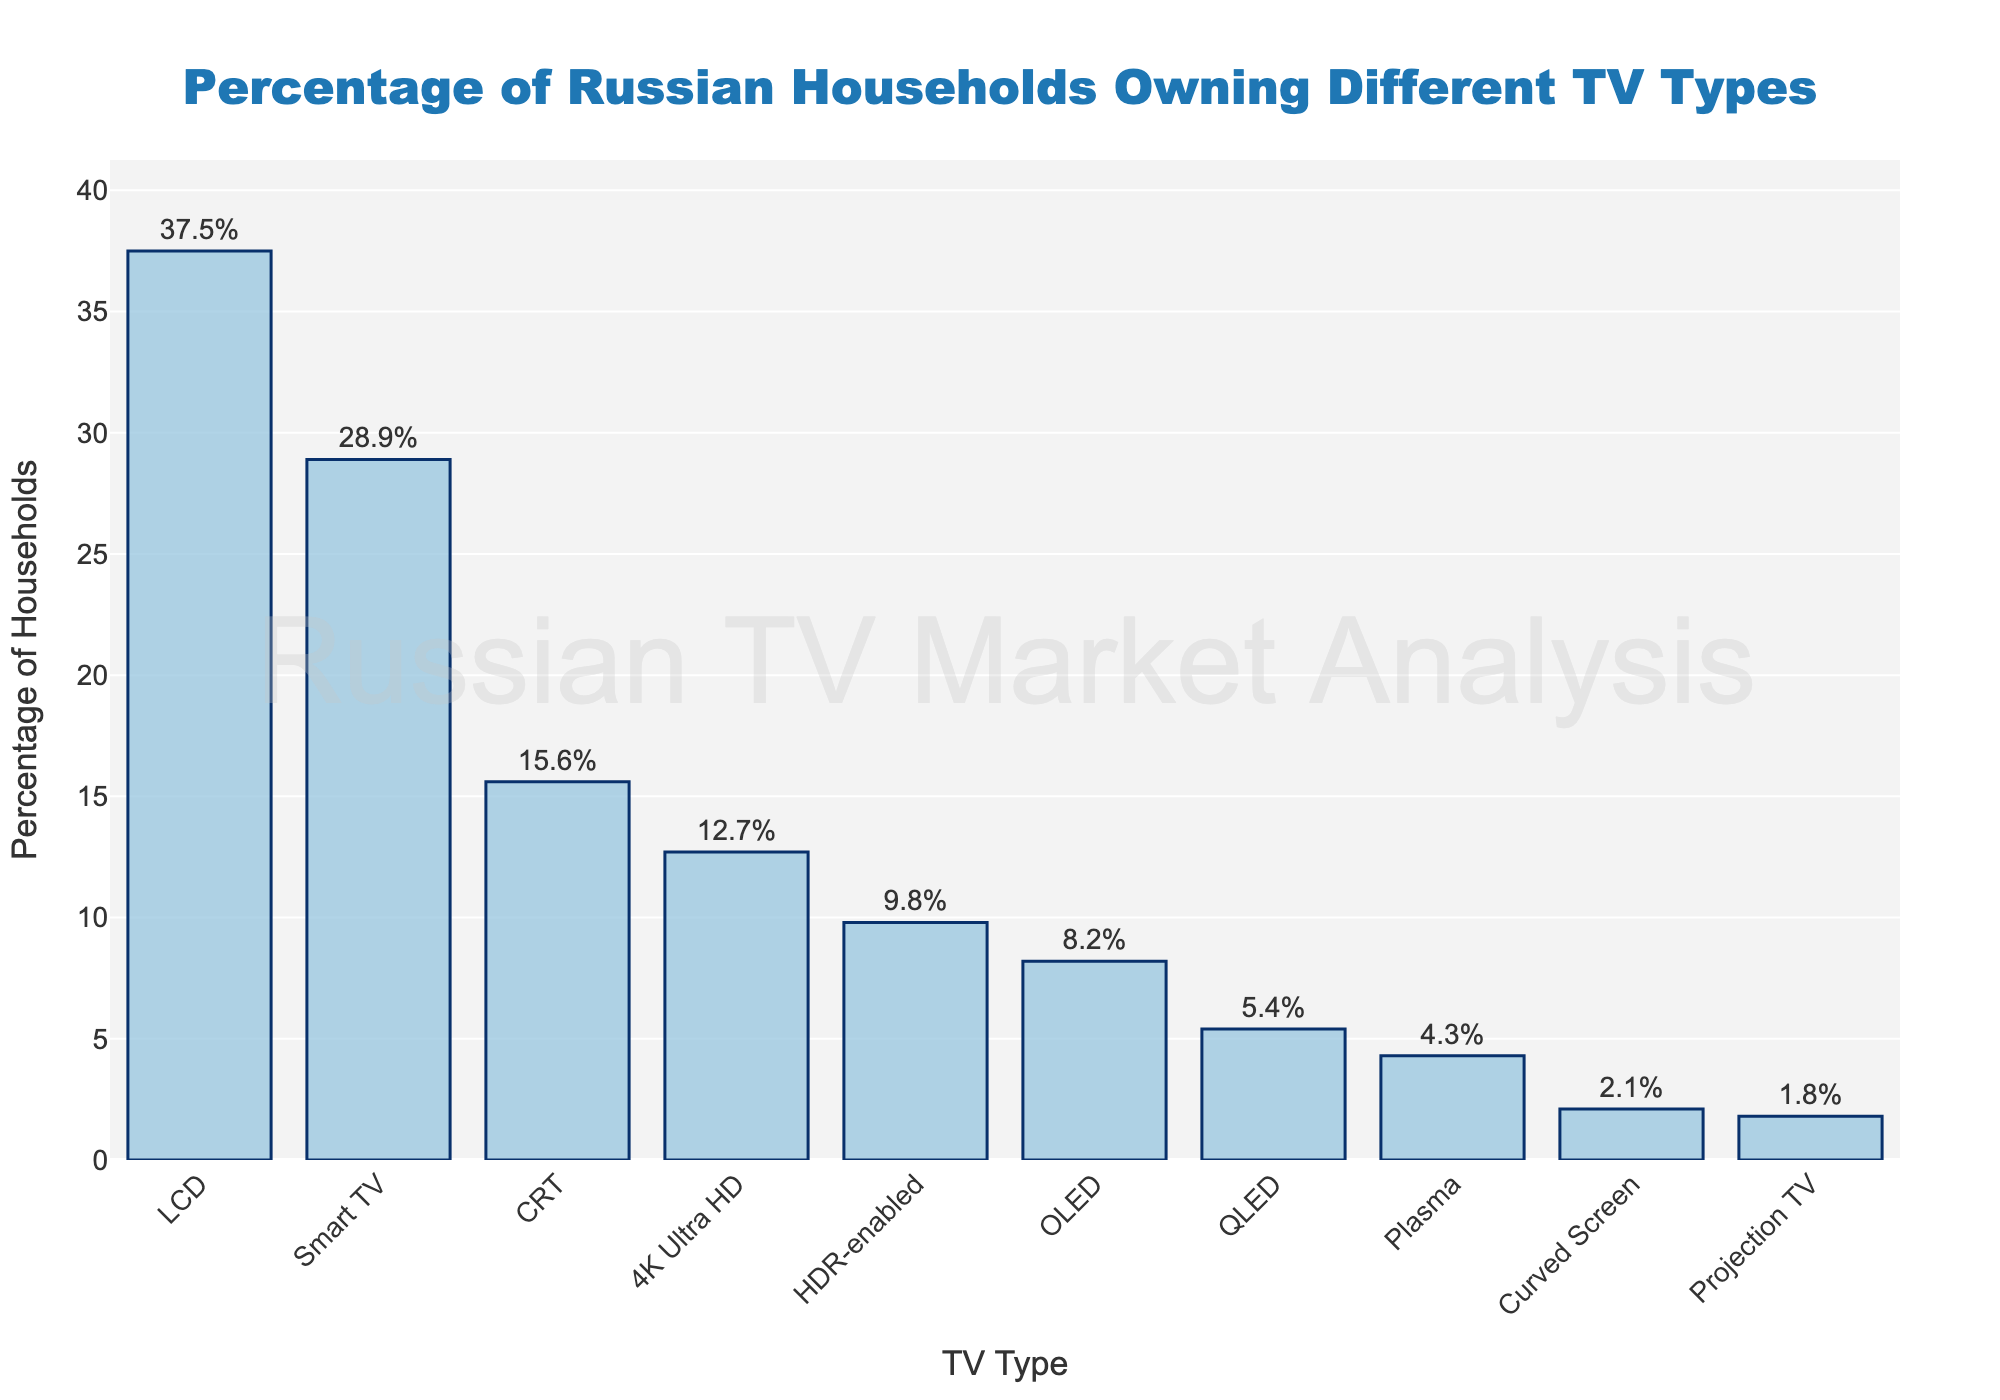Which type of TV is the most common in Russian households? The bar representing LCD TVs is the highest on the chart, so it is the most common TV type in Russian households with 37.5%.
Answer: LCD Which TV type has the lowest percentage of ownership? The bar representing Projection TV is the shortest on the chart, with a percentage of 1.8%, indicating it has the lowest percentage of ownership.
Answer: Projection TV Is the percentage of households that own CRT TVs higher than those that own OLED TVs? The bar for CRT TVs (15.6%) is higher than the bar for OLED TVs (8.2%), indicating CRT TV ownership is higher.
Answer: Yes Calculate the combined ownership percentage of Smart TVs and 4K Ultra HD TVs. Smart TVs have a percentage of 28.9% and 4K Ultra HD TVs have 12.7%. Adding these together: 28.9% + 12.7% = 41.6%.
Answer: 41.6% What is the difference in percentage between the most common TV type and the least common TV type? The most common TV type is LCD with 37.5%, and the least common is Projection TV with 1.8%. The difference is: 37.5% - 1.8% = 35.7%.
Answer: 35.7% Which TV types have a percentage of ownership below 10%? Viewing the chart, OLED (8.2%), Plasma (4.3%), Projection TV (1.8%), QLED (5.4%), HDR-enabled (9.8%), and Curved Screen (2.1%) have percentages below 10%.
Answer: OLED, Plasma, Projection TV, QLED, HDR-enabled, Curved Screen How many TV types have ownership percentages above 20%? By examining the bars, only LCD (37.5%) and Smart TV (28.9%) have ownership percentages above 20%.
Answer: 2 Which has a higher percentage of ownership: QLED or HDR-enabled TVs? The bar for HDR-enabled TVs (9.8%) is higher than that of QLED TVs (5.4%), indicating HDR-enabled TVs have a higher percentage of ownership.
Answer: HDR-enabled What is the average percentage of ownership of CRT, OLED, and Plasma TVs? Add up the percentages: CRT (15.6%), OLED (8.2%), Plasma (4.3%). Then, divide by the number of TV types (3): (15.6% + 8.2% + 4.3%) / 3 = 9.37%.
Answer: 9.37 Arrange the TV types in descending order of ownership percentage. The TV types arranged by ownership percentage in descending order are: LCD (37.5%), Smart TV (28.9%), CRT (15.6%), 4K Ultra HD (12.7%), HDR-enabled (9.8%), OLED (8.2%), QLED (5.4%), Plasma (4.3%), Curved Screen (2.1%), Projection TV (1.8%).
Answer: LCD, Smart TV, CRT, 4K Ultra HD, HDR-enabled, OLED, QLED, Plasma, Curved Screen, Projection TV 